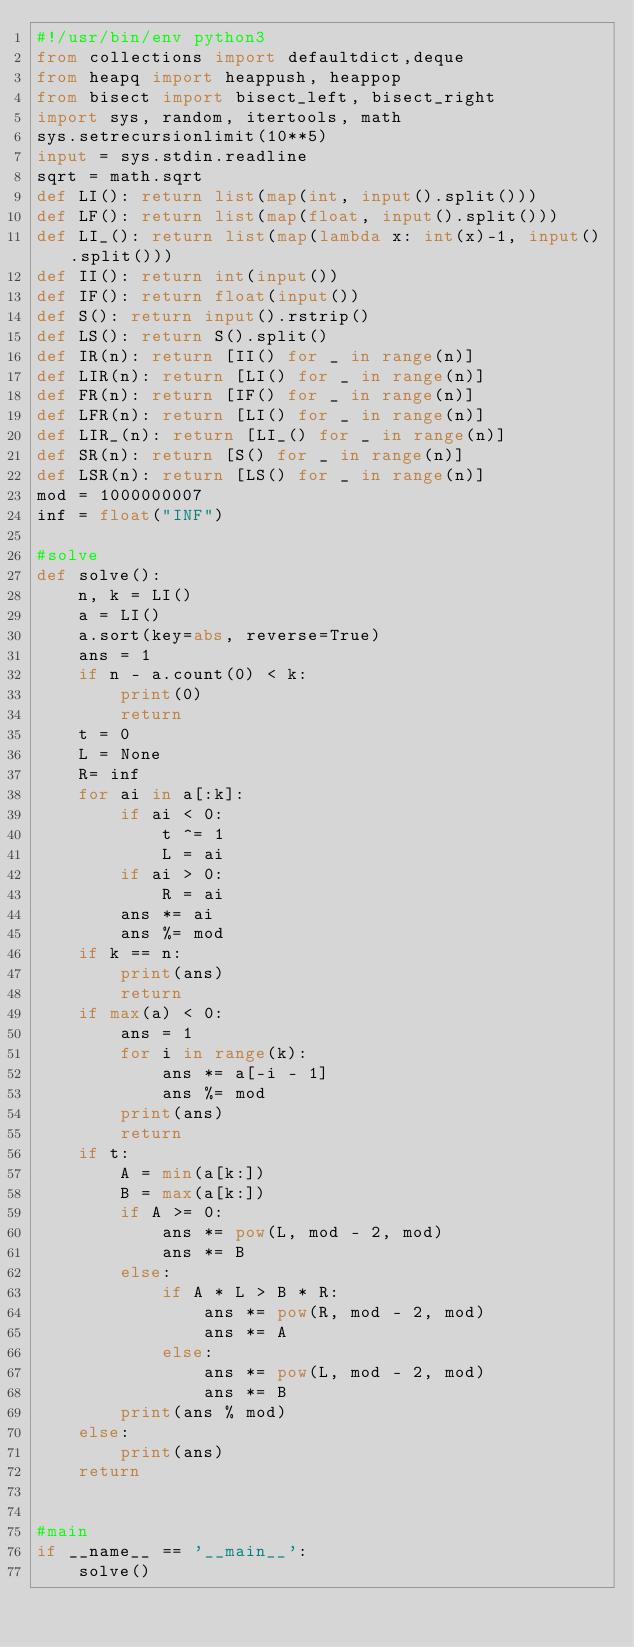<code> <loc_0><loc_0><loc_500><loc_500><_Python_>#!/usr/bin/env python3
from collections import defaultdict,deque
from heapq import heappush, heappop
from bisect import bisect_left, bisect_right
import sys, random, itertools, math
sys.setrecursionlimit(10**5)
input = sys.stdin.readline
sqrt = math.sqrt
def LI(): return list(map(int, input().split()))
def LF(): return list(map(float, input().split()))
def LI_(): return list(map(lambda x: int(x)-1, input().split()))
def II(): return int(input())
def IF(): return float(input())
def S(): return input().rstrip()
def LS(): return S().split()
def IR(n): return [II() for _ in range(n)]
def LIR(n): return [LI() for _ in range(n)]
def FR(n): return [IF() for _ in range(n)]
def LFR(n): return [LI() for _ in range(n)]
def LIR_(n): return [LI_() for _ in range(n)]
def SR(n): return [S() for _ in range(n)]
def LSR(n): return [LS() for _ in range(n)]
mod = 1000000007
inf = float("INF")

#solve
def solve():
    n, k = LI()
    a = LI()
    a.sort(key=abs, reverse=True)
    ans = 1
    if n - a.count(0) < k:
        print(0)
        return
    t = 0
    L = None
    R= inf
    for ai in a[:k]:
        if ai < 0:
            t ^= 1
            L = ai
        if ai > 0:
            R = ai
        ans *= ai
        ans %= mod
    if k == n:
        print(ans)
        return
    if max(a) < 0:
        ans = 1
        for i in range(k):
            ans *= a[-i - 1]
            ans %= mod
        print(ans)
        return
    if t:
        A = min(a[k:])
        B = max(a[k:])
        if A >= 0:
            ans *= pow(L, mod - 2, mod)
            ans *= B
        else:
            if A * L > B * R:
                ans *= pow(R, mod - 2, mod)
                ans *= A
            else:
                ans *= pow(L, mod - 2, mod)
                ans *= B
        print(ans % mod)
    else:
        print(ans)
    return


#main
if __name__ == '__main__':
    solve()
</code> 